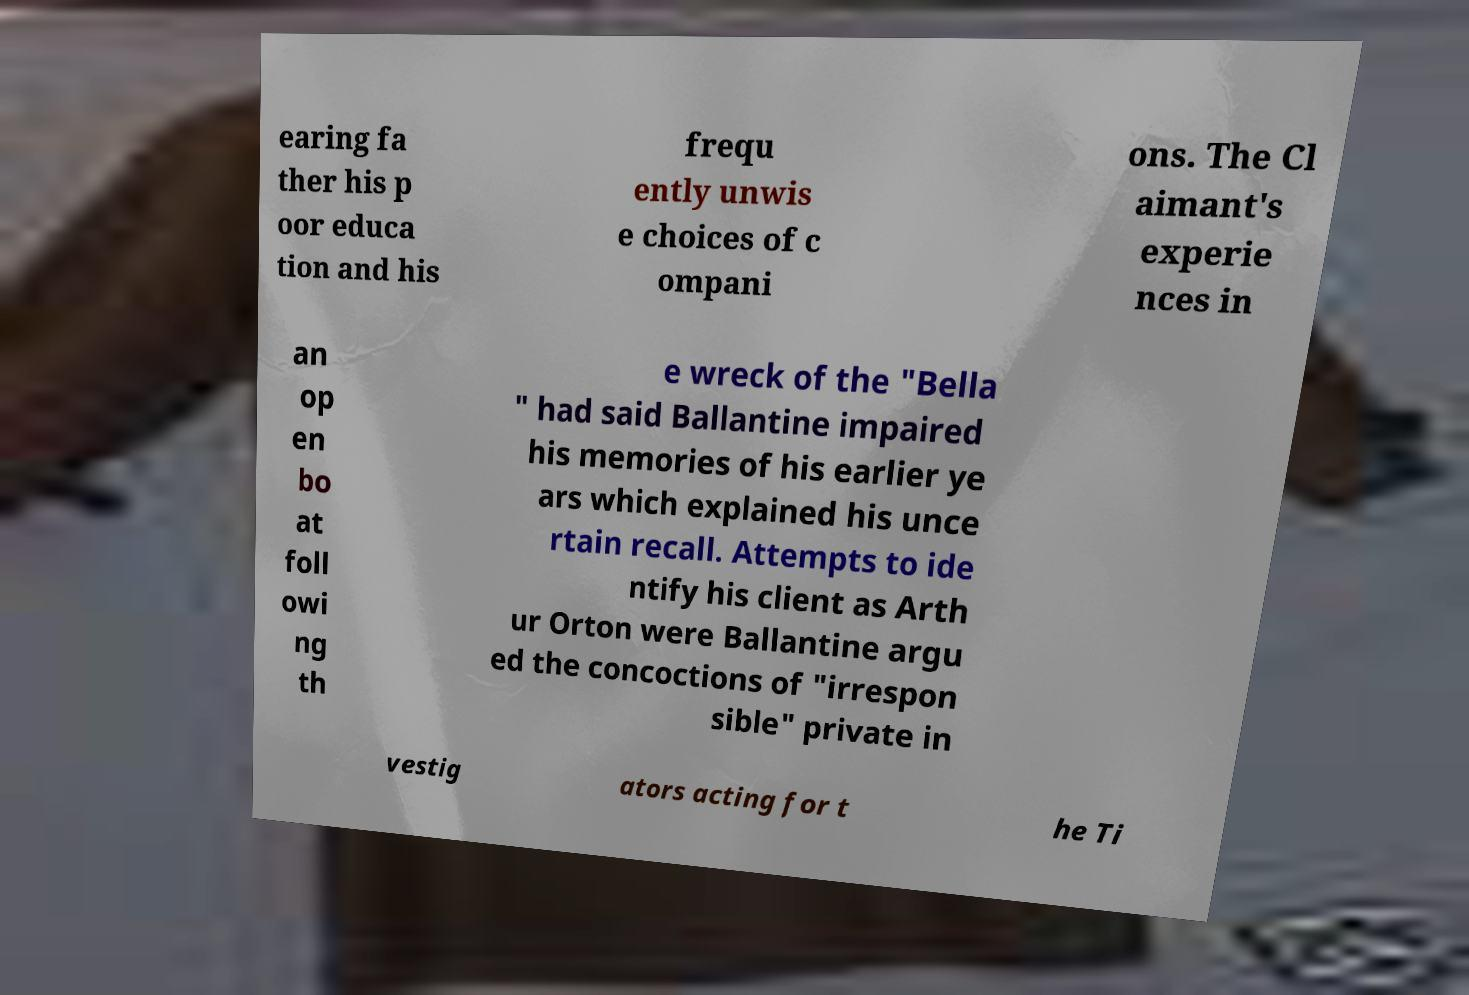Could you assist in decoding the text presented in this image and type it out clearly? earing fa ther his p oor educa tion and his frequ ently unwis e choices of c ompani ons. The Cl aimant's experie nces in an op en bo at foll owi ng th e wreck of the "Bella " had said Ballantine impaired his memories of his earlier ye ars which explained his unce rtain recall. Attempts to ide ntify his client as Arth ur Orton were Ballantine argu ed the concoctions of "irrespon sible" private in vestig ators acting for t he Ti 